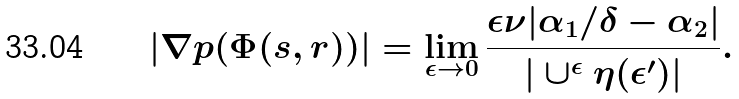<formula> <loc_0><loc_0><loc_500><loc_500>| \nabla p ( \Phi ( s , r ) ) | = \lim _ { \epsilon \to 0 } \frac { \epsilon \nu | \alpha _ { 1 } / \delta - \alpha _ { 2 } | } { | \cup ^ { \epsilon } \eta ( \epsilon ^ { \prime } ) | } .</formula> 